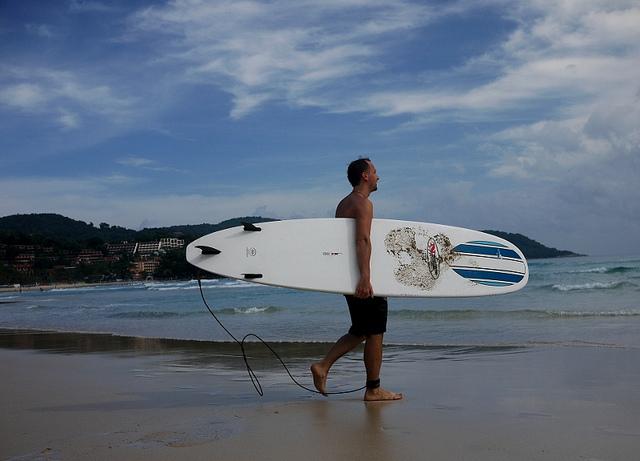Is that a shortboard?
Give a very brief answer. No. Do these boards have different uses?
Concise answer only. No. What object is painted on the surfboard?
Short answer required. Circle. What is the man holding?
Concise answer only. Surfboard. Is this at an airport?
Be succinct. No. What is he standing on?
Be succinct. Sand. What does the man have in his right hand?
Quick response, please. Surfboard. Is this an inland location?
Be succinct. No. Is the person wearing any protective gear?
Write a very short answer. No. Is the guy performing well?
Keep it brief. Yes. Is the shirtless man in trouble?
Give a very brief answer. No. What is the weather like?
Concise answer only. Sunny. 